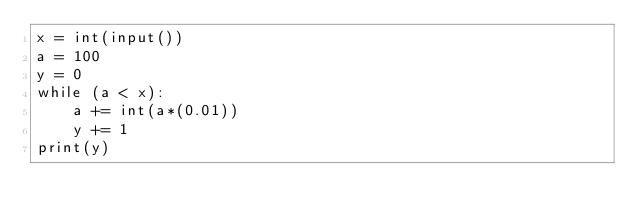Convert code to text. <code><loc_0><loc_0><loc_500><loc_500><_Python_>x = int(input())
a = 100
y = 0
while (a < x):
    a += int(a*(0.01))
    y += 1
print(y)</code> 